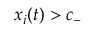<formula> <loc_0><loc_0><loc_500><loc_500>x _ { i } ( t ) > c _ { - }</formula> 